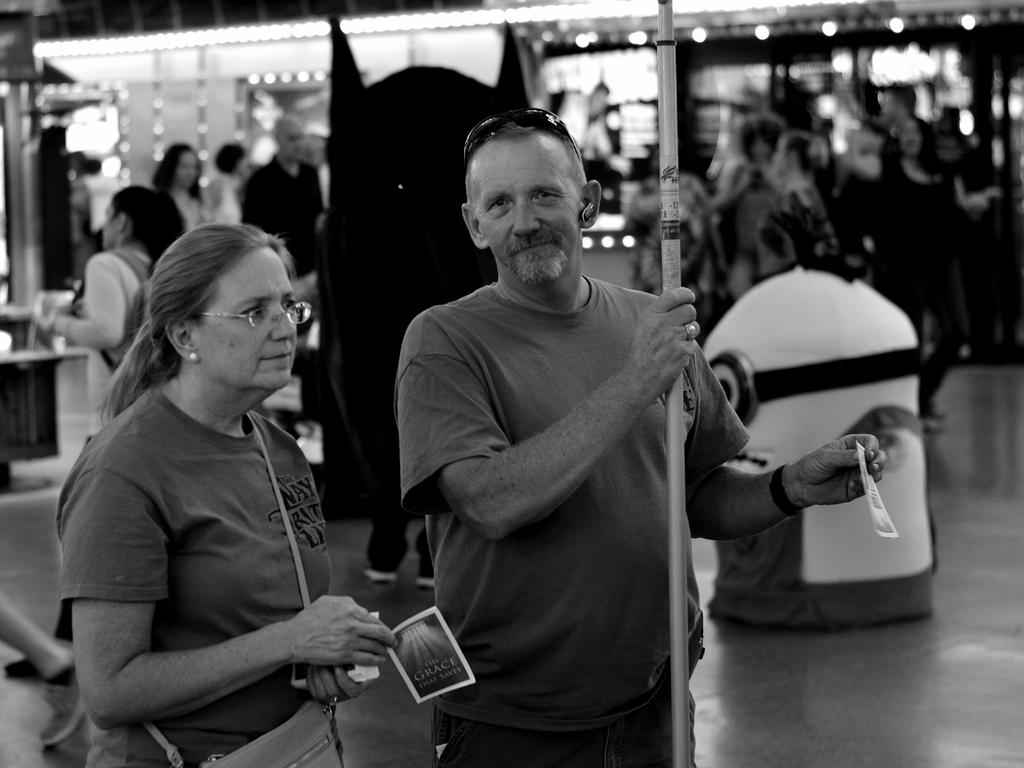Who or what can be seen in the image? There are people in the image. What else is present in the image besides the people? There is an object and a pole in the image. What can be seen in the background of the image? There are lights visible in the background of the image. What type of whistle can be heard in the image? There is no whistle present in the image, and therefore no sound can be heard. What color is the skirt worn by the person in the image? There is no person wearing a skirt in the image. 